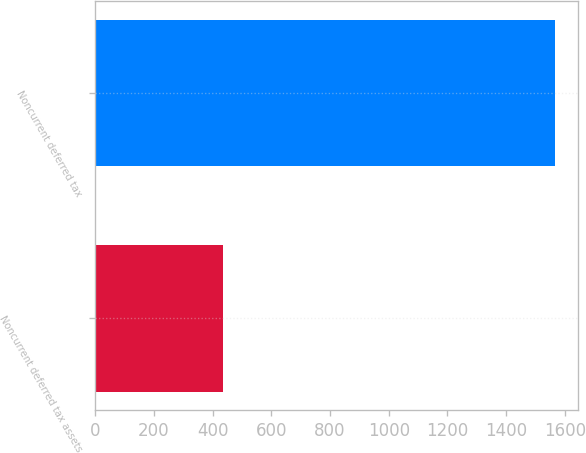<chart> <loc_0><loc_0><loc_500><loc_500><bar_chart><fcel>Noncurrent deferred tax assets<fcel>Noncurrent deferred tax<nl><fcel>435<fcel>1567<nl></chart> 